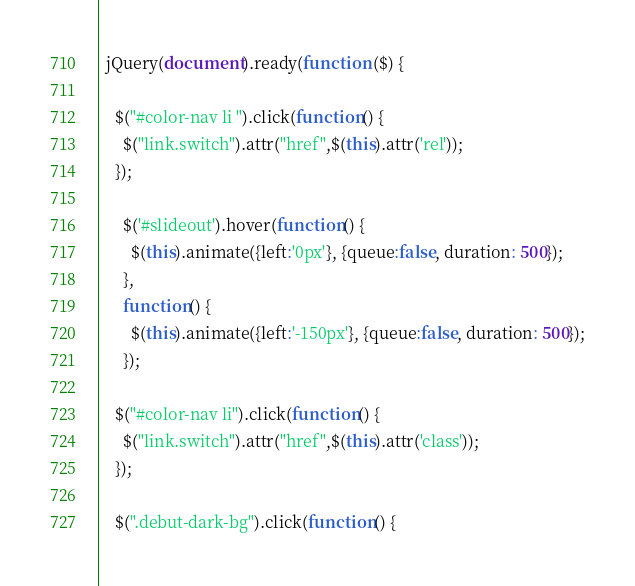<code> <loc_0><loc_0><loc_500><loc_500><_JavaScript_>  jQuery(document).ready(function ($) {
    
    $("#color-nav li ").click(function() { 
      $("link.switch").attr("href",$(this).attr('rel'));
    });
   
	  $('#slideout').hover(function() {
	    $(this).animate({left:'0px'}, {queue:false, duration: 500});
	  }, 
	  function() {
	    $(this).animate({left:'-150px'}, {queue:false, duration: 500});
	  });
	  
    $("#color-nav li").click(function() { 
      $("link.switch").attr("href",$(this).attr('class'));
    });
    
    $(".debut-dark-bg").click(function() {</code> 